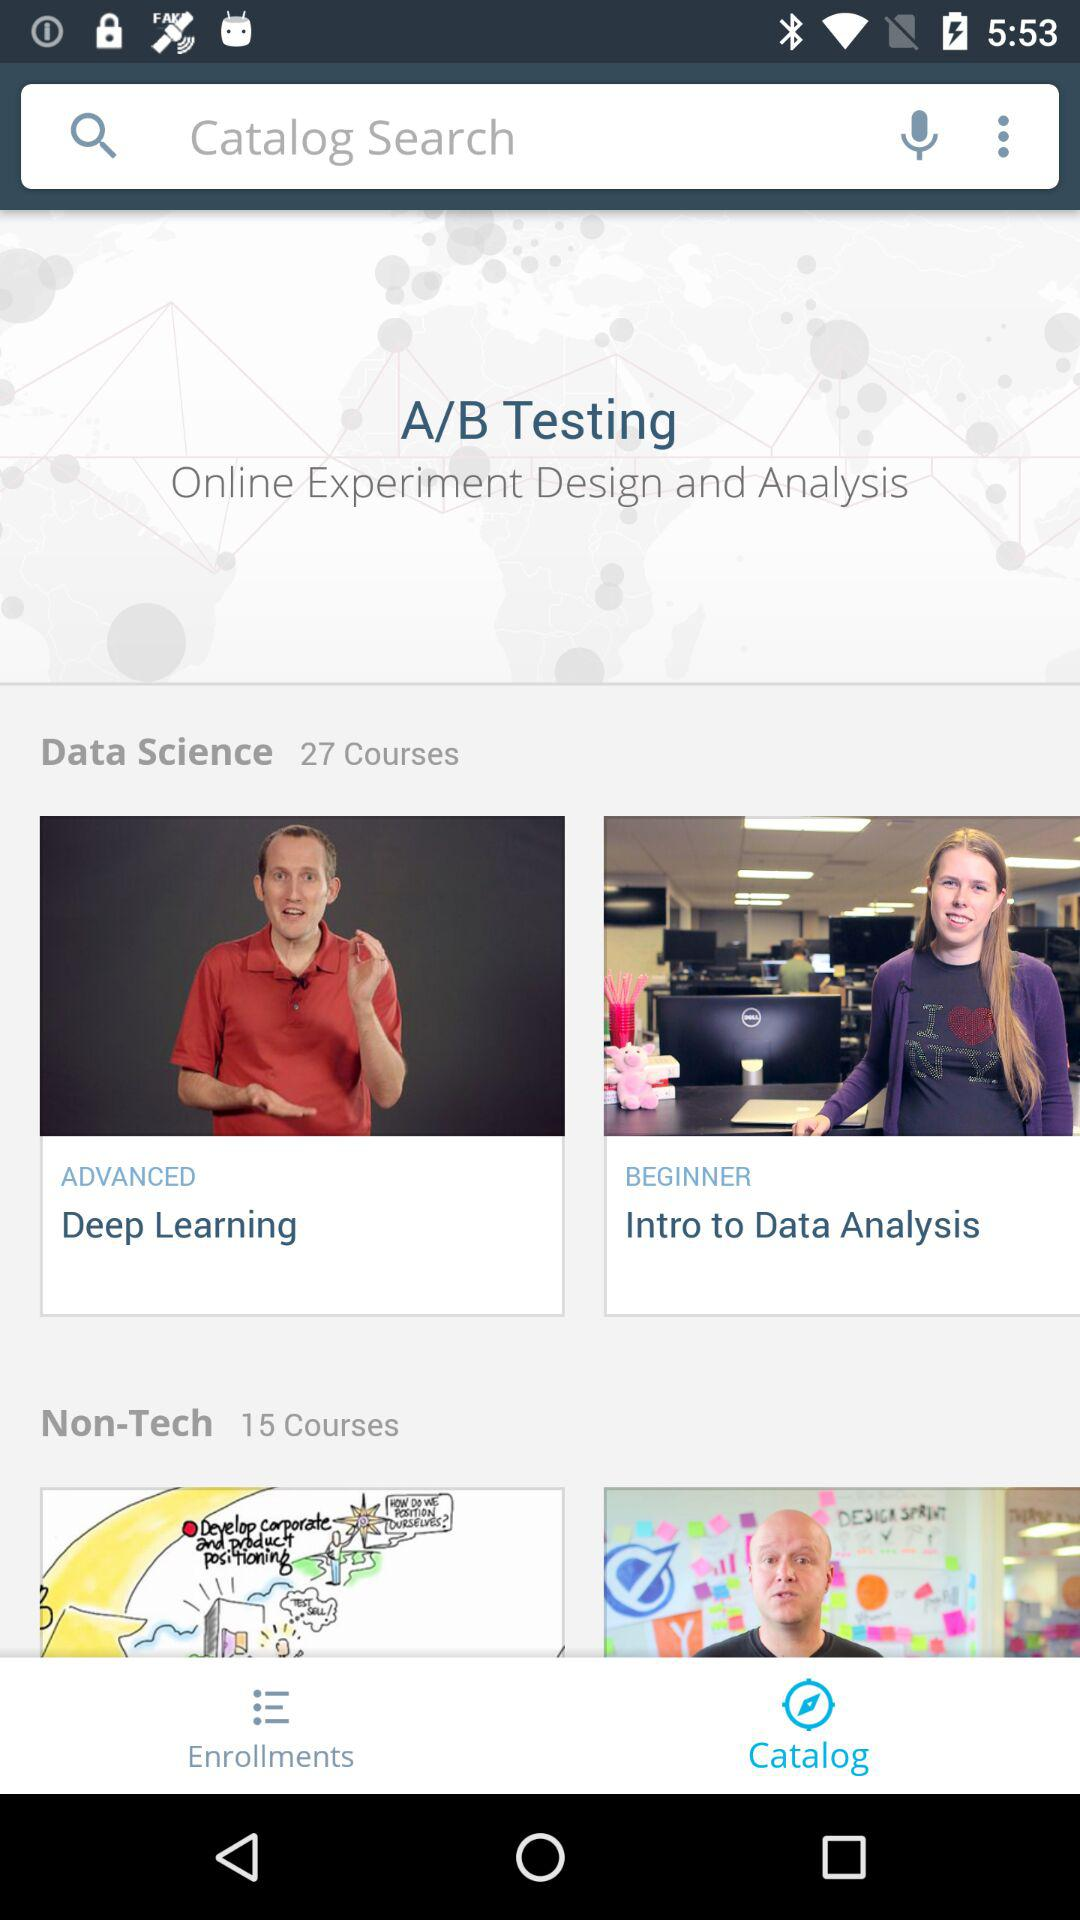What is the total number of non-tech courses? The total number of non-tech courses is 15. 